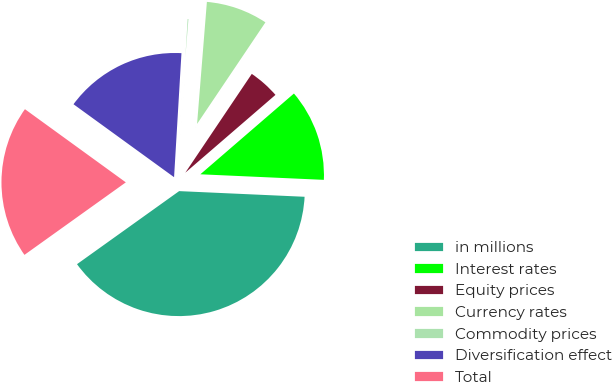<chart> <loc_0><loc_0><loc_500><loc_500><pie_chart><fcel>in millions<fcel>Interest rates<fcel>Equity prices<fcel>Currency rates<fcel>Commodity prices<fcel>Diversification effect<fcel>Total<nl><fcel>39.4%<fcel>12.05%<fcel>4.24%<fcel>8.15%<fcel>0.33%<fcel>15.96%<fcel>19.87%<nl></chart> 